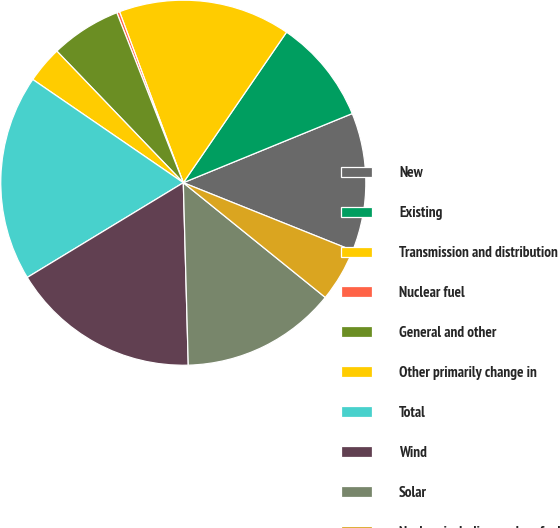Convert chart to OTSL. <chart><loc_0><loc_0><loc_500><loc_500><pie_chart><fcel>New<fcel>Existing<fcel>Transmission and distribution<fcel>Nuclear fuel<fcel>General and other<fcel>Other primarily change in<fcel>Total<fcel>Wind<fcel>Solar<fcel>Nuclear including nuclear fuel<nl><fcel>12.25%<fcel>9.25%<fcel>15.25%<fcel>0.25%<fcel>6.25%<fcel>3.25%<fcel>18.25%<fcel>16.75%<fcel>13.75%<fcel>4.75%<nl></chart> 